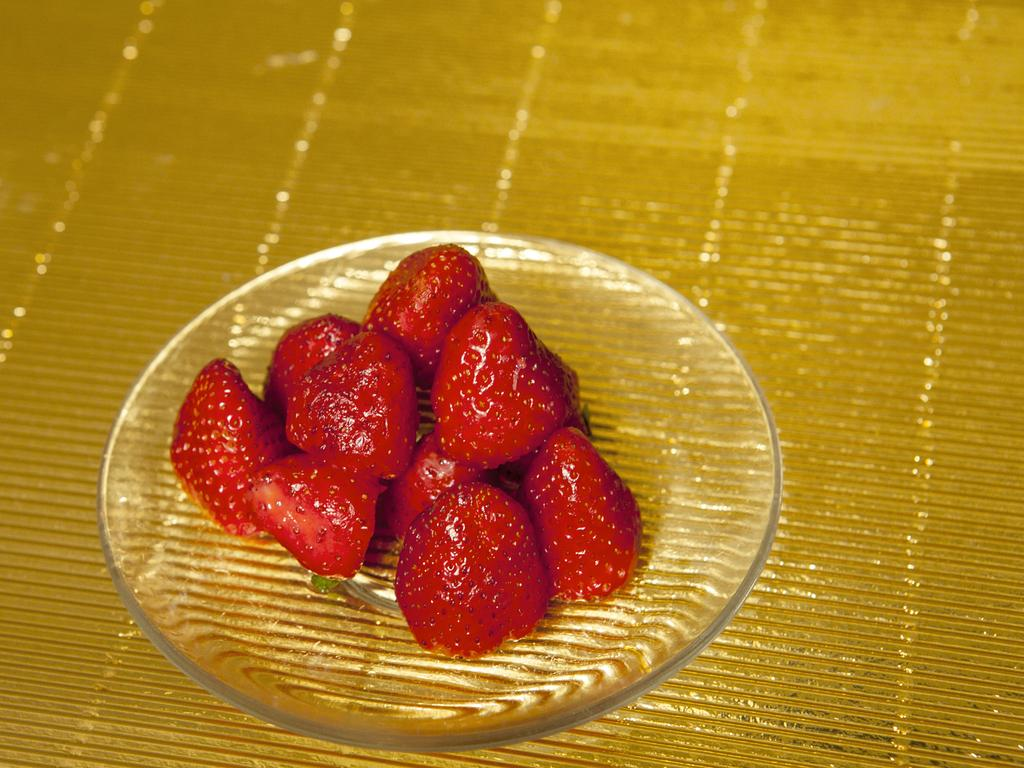What type of fruit is present in the image? There are strawberries in the image. How are the strawberries arranged or displayed in the image? The strawberries are in a glass plate. What type of guide is present in the image? There is no guide present in the image; it only features strawberries in a glass plate. 